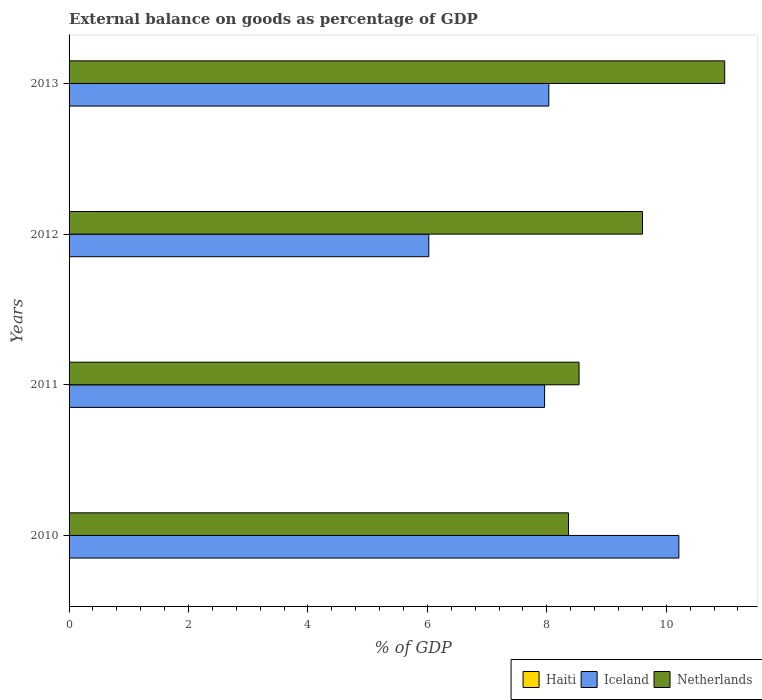Are the number of bars per tick equal to the number of legend labels?
Give a very brief answer. No. Are the number of bars on each tick of the Y-axis equal?
Give a very brief answer. Yes. How many bars are there on the 4th tick from the top?
Your response must be concise. 2. How many bars are there on the 1st tick from the bottom?
Give a very brief answer. 2. What is the label of the 2nd group of bars from the top?
Provide a short and direct response. 2012. What is the external balance on goods as percentage of GDP in Iceland in 2011?
Keep it short and to the point. 7.96. Across all years, what is the maximum external balance on goods as percentage of GDP in Iceland?
Offer a very short reply. 10.21. In which year was the external balance on goods as percentage of GDP in Netherlands maximum?
Ensure brevity in your answer.  2013. What is the total external balance on goods as percentage of GDP in Netherlands in the graph?
Provide a succinct answer. 37.48. What is the difference between the external balance on goods as percentage of GDP in Netherlands in 2010 and that in 2011?
Your response must be concise. -0.18. What is the difference between the external balance on goods as percentage of GDP in Iceland in 2010 and the external balance on goods as percentage of GDP in Haiti in 2011?
Offer a terse response. 10.21. What is the average external balance on goods as percentage of GDP in Haiti per year?
Your answer should be compact. 0. In the year 2010, what is the difference between the external balance on goods as percentage of GDP in Netherlands and external balance on goods as percentage of GDP in Iceland?
Keep it short and to the point. -1.85. What is the ratio of the external balance on goods as percentage of GDP in Netherlands in 2011 to that in 2013?
Ensure brevity in your answer.  0.78. Is the external balance on goods as percentage of GDP in Iceland in 2011 less than that in 2012?
Your answer should be very brief. No. Is the difference between the external balance on goods as percentage of GDP in Netherlands in 2011 and 2012 greater than the difference between the external balance on goods as percentage of GDP in Iceland in 2011 and 2012?
Your answer should be compact. No. What is the difference between the highest and the second highest external balance on goods as percentage of GDP in Netherlands?
Provide a succinct answer. 1.38. What is the difference between the highest and the lowest external balance on goods as percentage of GDP in Iceland?
Your answer should be very brief. 4.19. Is the sum of the external balance on goods as percentage of GDP in Iceland in 2011 and 2013 greater than the maximum external balance on goods as percentage of GDP in Haiti across all years?
Offer a very short reply. Yes. Are all the bars in the graph horizontal?
Your response must be concise. Yes. Does the graph contain any zero values?
Your answer should be very brief. Yes. Does the graph contain grids?
Keep it short and to the point. No. Where does the legend appear in the graph?
Ensure brevity in your answer.  Bottom right. How many legend labels are there?
Your answer should be very brief. 3. What is the title of the graph?
Give a very brief answer. External balance on goods as percentage of GDP. Does "Uzbekistan" appear as one of the legend labels in the graph?
Your response must be concise. No. What is the label or title of the X-axis?
Your response must be concise. % of GDP. What is the label or title of the Y-axis?
Make the answer very short. Years. What is the % of GDP in Iceland in 2010?
Offer a terse response. 10.21. What is the % of GDP in Netherlands in 2010?
Give a very brief answer. 8.36. What is the % of GDP of Iceland in 2011?
Your answer should be very brief. 7.96. What is the % of GDP in Netherlands in 2011?
Your answer should be compact. 8.54. What is the % of GDP of Haiti in 2012?
Give a very brief answer. 0. What is the % of GDP in Iceland in 2012?
Ensure brevity in your answer.  6.02. What is the % of GDP in Netherlands in 2012?
Your answer should be compact. 9.6. What is the % of GDP of Haiti in 2013?
Your answer should be very brief. 0. What is the % of GDP of Iceland in 2013?
Your response must be concise. 8.03. What is the % of GDP of Netherlands in 2013?
Offer a very short reply. 10.98. Across all years, what is the maximum % of GDP in Iceland?
Ensure brevity in your answer.  10.21. Across all years, what is the maximum % of GDP of Netherlands?
Your answer should be very brief. 10.98. Across all years, what is the minimum % of GDP in Iceland?
Offer a very short reply. 6.02. Across all years, what is the minimum % of GDP of Netherlands?
Your response must be concise. 8.36. What is the total % of GDP of Haiti in the graph?
Provide a succinct answer. 0. What is the total % of GDP in Iceland in the graph?
Offer a very short reply. 32.23. What is the total % of GDP in Netherlands in the graph?
Offer a terse response. 37.48. What is the difference between the % of GDP of Iceland in 2010 and that in 2011?
Offer a terse response. 2.25. What is the difference between the % of GDP in Netherlands in 2010 and that in 2011?
Your response must be concise. -0.18. What is the difference between the % of GDP in Iceland in 2010 and that in 2012?
Keep it short and to the point. 4.19. What is the difference between the % of GDP in Netherlands in 2010 and that in 2012?
Offer a very short reply. -1.24. What is the difference between the % of GDP of Iceland in 2010 and that in 2013?
Your answer should be compact. 2.18. What is the difference between the % of GDP in Netherlands in 2010 and that in 2013?
Your answer should be very brief. -2.62. What is the difference between the % of GDP in Iceland in 2011 and that in 2012?
Your answer should be compact. 1.94. What is the difference between the % of GDP of Netherlands in 2011 and that in 2012?
Your answer should be compact. -1.06. What is the difference between the % of GDP in Iceland in 2011 and that in 2013?
Your response must be concise. -0.07. What is the difference between the % of GDP of Netherlands in 2011 and that in 2013?
Ensure brevity in your answer.  -2.44. What is the difference between the % of GDP of Iceland in 2012 and that in 2013?
Ensure brevity in your answer.  -2.01. What is the difference between the % of GDP of Netherlands in 2012 and that in 2013?
Make the answer very short. -1.38. What is the difference between the % of GDP of Iceland in 2010 and the % of GDP of Netherlands in 2011?
Keep it short and to the point. 1.67. What is the difference between the % of GDP of Iceland in 2010 and the % of GDP of Netherlands in 2012?
Give a very brief answer. 0.61. What is the difference between the % of GDP of Iceland in 2010 and the % of GDP of Netherlands in 2013?
Your answer should be very brief. -0.77. What is the difference between the % of GDP of Iceland in 2011 and the % of GDP of Netherlands in 2012?
Ensure brevity in your answer.  -1.64. What is the difference between the % of GDP of Iceland in 2011 and the % of GDP of Netherlands in 2013?
Your response must be concise. -3.02. What is the difference between the % of GDP of Iceland in 2012 and the % of GDP of Netherlands in 2013?
Your answer should be compact. -4.95. What is the average % of GDP in Haiti per year?
Give a very brief answer. 0. What is the average % of GDP of Iceland per year?
Your answer should be very brief. 8.06. What is the average % of GDP in Netherlands per year?
Ensure brevity in your answer.  9.37. In the year 2010, what is the difference between the % of GDP in Iceland and % of GDP in Netherlands?
Offer a very short reply. 1.85. In the year 2011, what is the difference between the % of GDP in Iceland and % of GDP in Netherlands?
Your response must be concise. -0.58. In the year 2012, what is the difference between the % of GDP in Iceland and % of GDP in Netherlands?
Ensure brevity in your answer.  -3.58. In the year 2013, what is the difference between the % of GDP in Iceland and % of GDP in Netherlands?
Give a very brief answer. -2.94. What is the ratio of the % of GDP of Iceland in 2010 to that in 2011?
Ensure brevity in your answer.  1.28. What is the ratio of the % of GDP in Netherlands in 2010 to that in 2011?
Offer a very short reply. 0.98. What is the ratio of the % of GDP of Iceland in 2010 to that in 2012?
Offer a very short reply. 1.7. What is the ratio of the % of GDP in Netherlands in 2010 to that in 2012?
Your response must be concise. 0.87. What is the ratio of the % of GDP of Iceland in 2010 to that in 2013?
Your answer should be very brief. 1.27. What is the ratio of the % of GDP of Netherlands in 2010 to that in 2013?
Provide a short and direct response. 0.76. What is the ratio of the % of GDP in Iceland in 2011 to that in 2012?
Give a very brief answer. 1.32. What is the ratio of the % of GDP in Netherlands in 2011 to that in 2012?
Ensure brevity in your answer.  0.89. What is the ratio of the % of GDP in Iceland in 2011 to that in 2013?
Provide a short and direct response. 0.99. What is the ratio of the % of GDP in Netherlands in 2011 to that in 2013?
Give a very brief answer. 0.78. What is the ratio of the % of GDP of Iceland in 2012 to that in 2013?
Ensure brevity in your answer.  0.75. What is the ratio of the % of GDP in Netherlands in 2012 to that in 2013?
Offer a terse response. 0.87. What is the difference between the highest and the second highest % of GDP of Iceland?
Give a very brief answer. 2.18. What is the difference between the highest and the second highest % of GDP in Netherlands?
Offer a very short reply. 1.38. What is the difference between the highest and the lowest % of GDP of Iceland?
Your answer should be compact. 4.19. What is the difference between the highest and the lowest % of GDP of Netherlands?
Give a very brief answer. 2.62. 